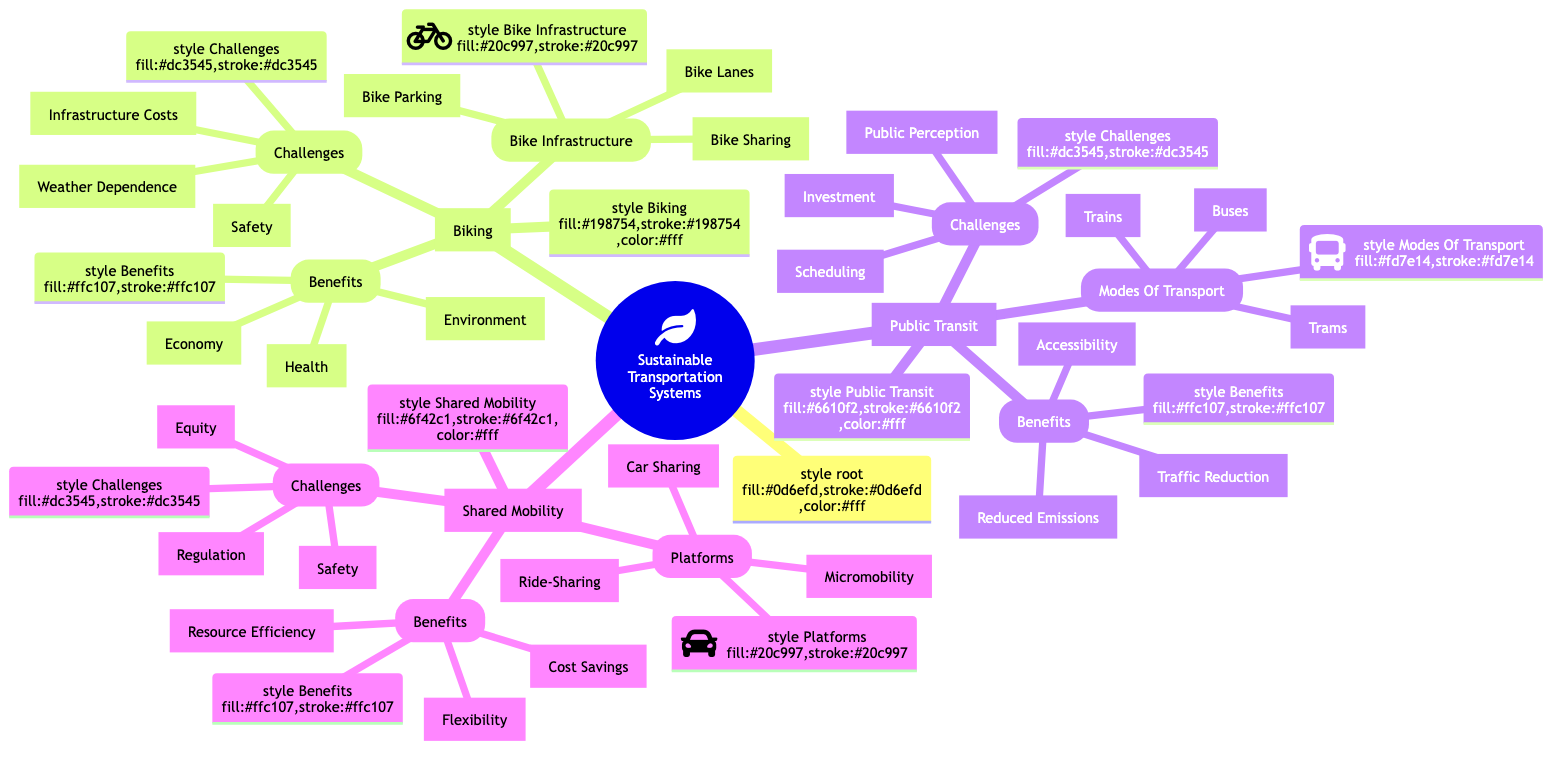What are the three main categories in the mind map? The main categories in the mind map are Biking, Public Transit, and Shared Mobility. These are the primary nodes branching from the root.
Answer: Biking, Public Transit, Shared Mobility How many benefits are associated with Biking? Under the Biking category, there are three benefits listed: Health, Environment, and Economy. Each of these is a separate node under Benefits.
Answer: 3 What is a challenge of Shared Mobility? One of the challenges listed under Shared Mobility is Regulation, which is shown as a separate node under the Challenges category.
Answer: Regulation What are the modes of transport listed under Public Transit? The modes of transport include Buses, Trains, and Trams, which are specifically delineated in the Modes Of Transport subsection.
Answer: Buses, Trains, Trams Which system has an emphasis on resource efficiency? Shared Mobility emphasizes resource efficiency, as stated in the Benefits section under Shared Mobility.
Answer: Shared Mobility What is the relationship between Biking and its Benefits? Biking is related to its Benefits through a direct connection, indicating that Biking has specific positive impacts on Health, Environment, and Economy.
Answer: Direct connection What is one of the challenges faced by public transit systems? One challenge faced by public transit systems is Investment, which involves the high cost of building and maintaining transit infrastructure.
Answer: Investment How many types of bike infrastructure are mentioned? There are three types of bike infrastructure mentioned: Bike Lanes, Bike Parking, and Bike Sharing, each listed as a separate node.
Answer: 3 Which platform exists under Shared Mobility? Ride-Sharing is one of the platforms that exists under Shared Mobility, among others.
Answer: Ride-Sharing 